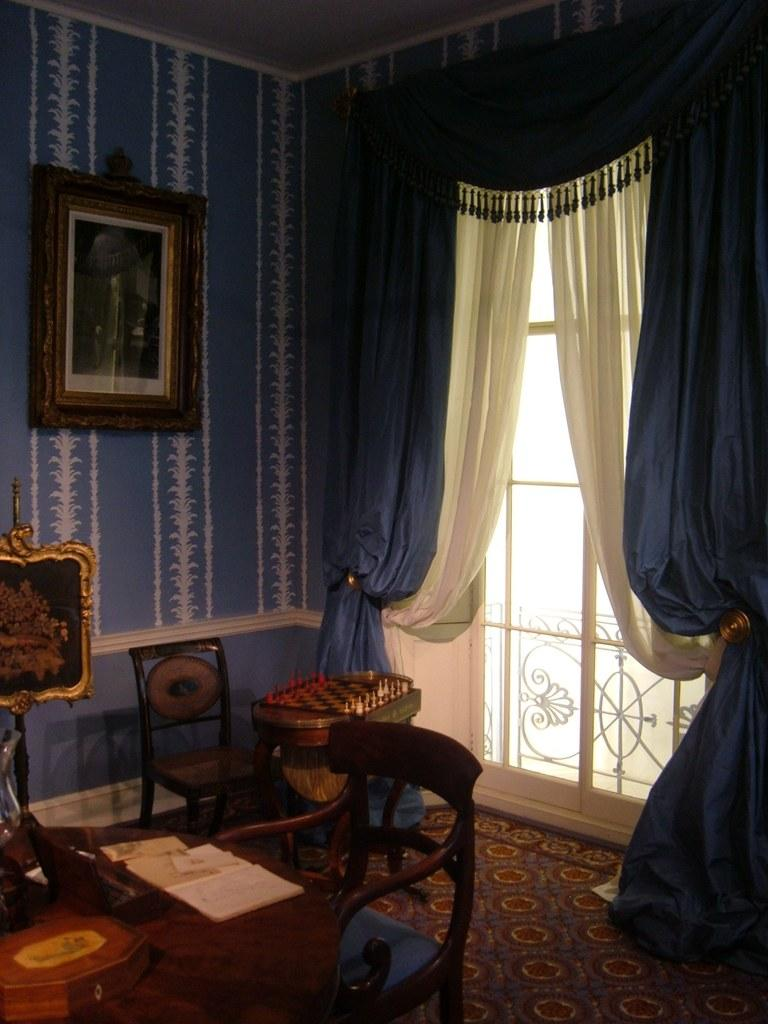What type of furniture is present in the image? There are chairs and a table in the image. What is on top of the table? A box and books are present on the table. What is hanging on the wall? There is a frame on the wall. What type of game can be seen in the image? A chess board is visible in the image. What is the source of natural light in the room? There is a window in the image, and curtains are associated with the window. What type of selection is being made by the turkey in the image? There is no turkey present in the image, so it is not possible to answer that question. 